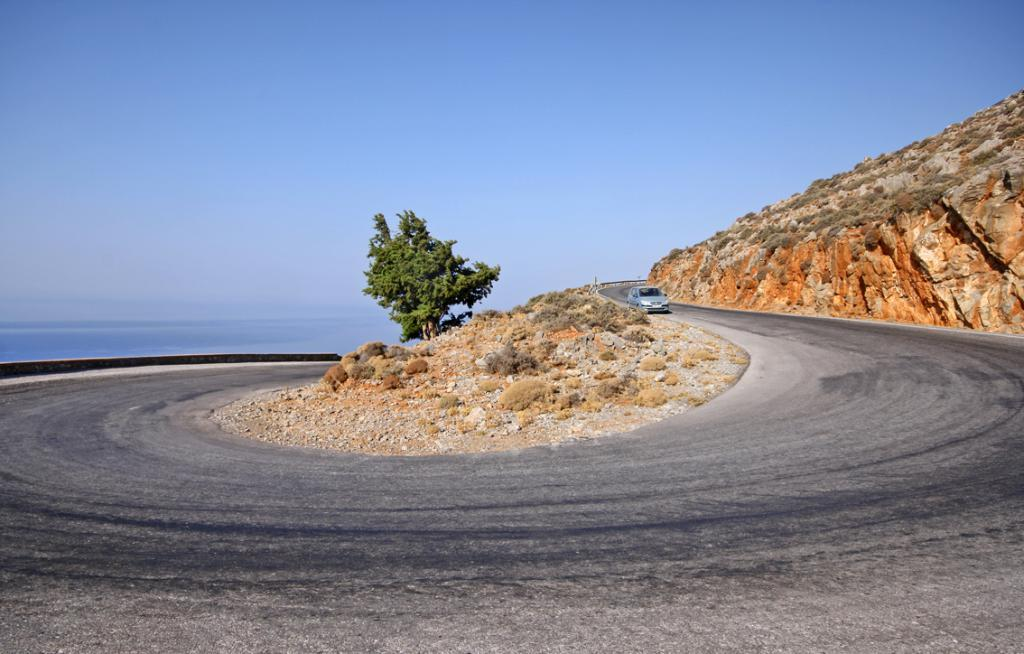What is the main subject of the image? There is a car on the road in the image. What else can be seen on the road? There are stones visible in the image. What natural elements are present in the image? There is a tree and plants in the image. What type of terrain is visible in the image? The hill is visible in the image. How would you describe the weather in the image? The sky is cloudy in the image. Can you see the grandfather wearing a cap in the image? There is no grandfather or cap present in the image. What type of support is the tree using to stand in the image? The tree does not require any support to stand in the image; it is a natural element that can stand on its own. 